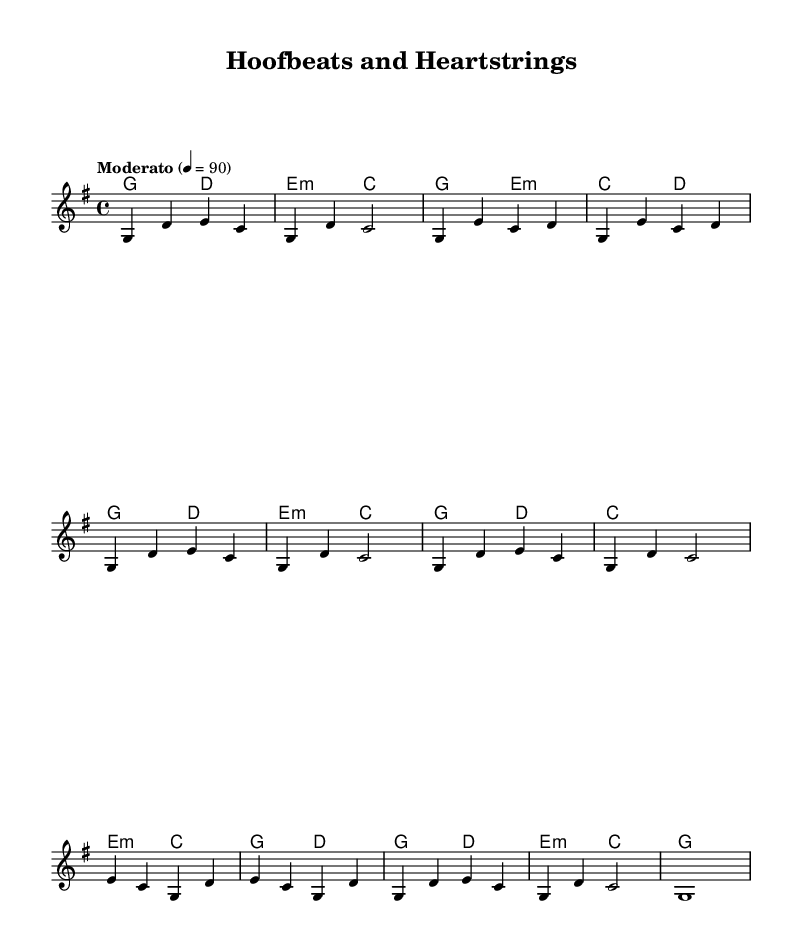What is the key signature of this music? The key signature is G major, indicated by one sharp (F#) present on the staff.
Answer: G major What is the time signature of this music? The time signature is 4/4, which shows there are four beats per measure.
Answer: 4/4 What is the tempo marking for this piece? The tempo marking is "Moderato," which is indicated at the beginning of the piece.
Answer: Moderato How many measures are in the chorus section? The chorus is represented by two repeated sections, each containing four measures, making a total of eight measures in the chorus.
Answer: 8 What is the primary theme explored in the song? The primary theme is the bond between humans and animals, which is suggested by the title and musical elements.
Answer: Bond between humans and animals Which chord is used most frequently in the chorus? The chord G major is used more frequently, appearing at the start of both repeated sections.
Answer: G major 